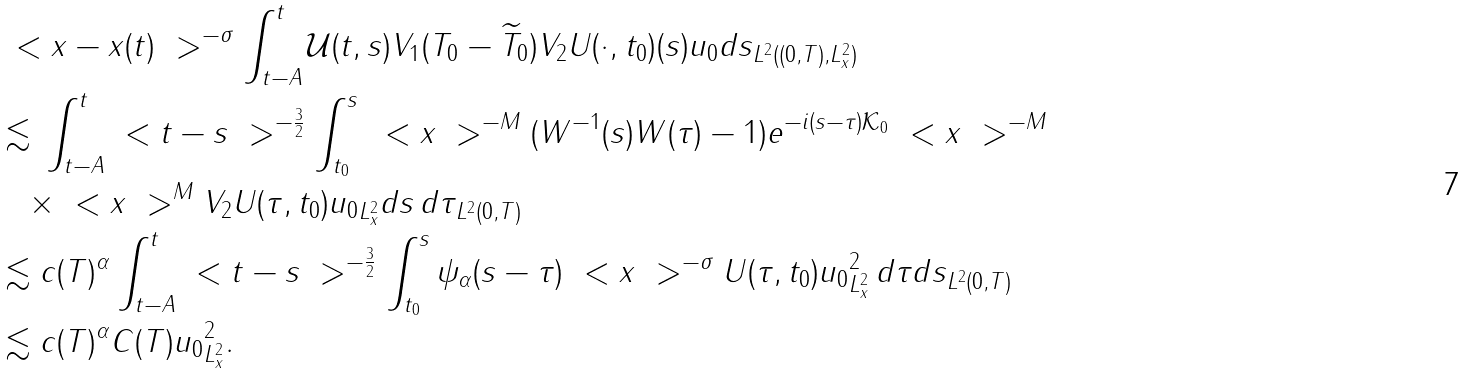Convert formula to latex. <formula><loc_0><loc_0><loc_500><loc_500>& \| \ < x - x ( t ) \ > ^ { - \sigma } \int _ { t - A } ^ { t } \mathcal { U } ( t , s ) V _ { 1 } ( { T } _ { 0 } - \widetilde { T } _ { 0 } ) V _ { 2 } U ( \cdot , t _ { 0 } ) ( s ) u _ { 0 } d s \| _ { L ^ { 2 } ( ( 0 , T ) , L ^ { 2 } _ { x } ) } \\ & \lesssim \| \int _ { t - A } ^ { t } \ < t - s \ > ^ { - \frac { 3 } { 2 } } \int _ { t _ { 0 } } ^ { s } \| \ < x \ > ^ { - M } ( W ^ { - 1 } ( s ) W ( \tau ) - 1 ) e ^ { - i ( s - \tau ) \mathcal { K } _ { 0 } } \ < x \ > ^ { - M } \\ & \quad \times \ < x \ > ^ { M } V _ { 2 } U ( \tau , t _ { 0 } ) u _ { 0 } \| _ { L ^ { 2 } _ { x } } d s \, d \tau \| _ { L ^ { 2 } ( 0 , T ) } \\ & \lesssim c ( T ) ^ { \alpha } \| \int _ { t - A } ^ { t } \ < t - s \ > ^ { - \frac { 3 } { 2 } } \int _ { t _ { 0 } } ^ { s } \psi _ { \alpha } ( s - \tau ) \| \ < x \ > ^ { - \sigma } U ( \tau , t _ { 0 } ) u _ { 0 } \| _ { L ^ { 2 } _ { x } } ^ { 2 } \, d \tau d s \| _ { L ^ { 2 } ( 0 , T ) } \\ & \lesssim c ( T ) ^ { \alpha } C ( T ) \| u _ { 0 } \| _ { L ^ { 2 } _ { x } } ^ { 2 } .</formula> 